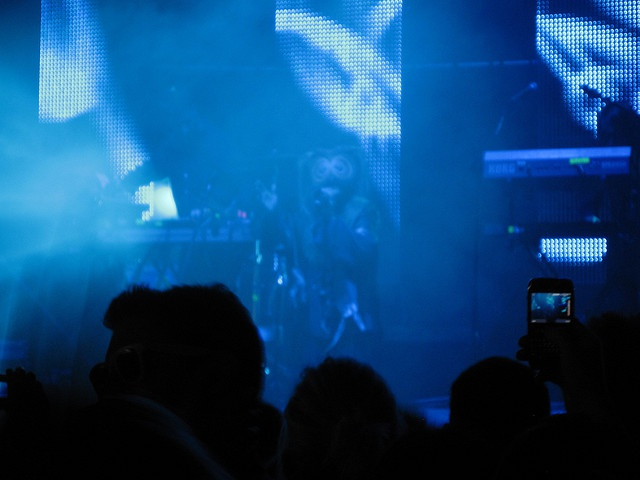Describe the objects in this image and their specific colors. I can see people in navy, black, and blue tones, people in navy and black tones, people in navy, black, darkblue, and blue tones, people in navy, blue, and darkblue tones, and people in black, navy, and darkblue tones in this image. 